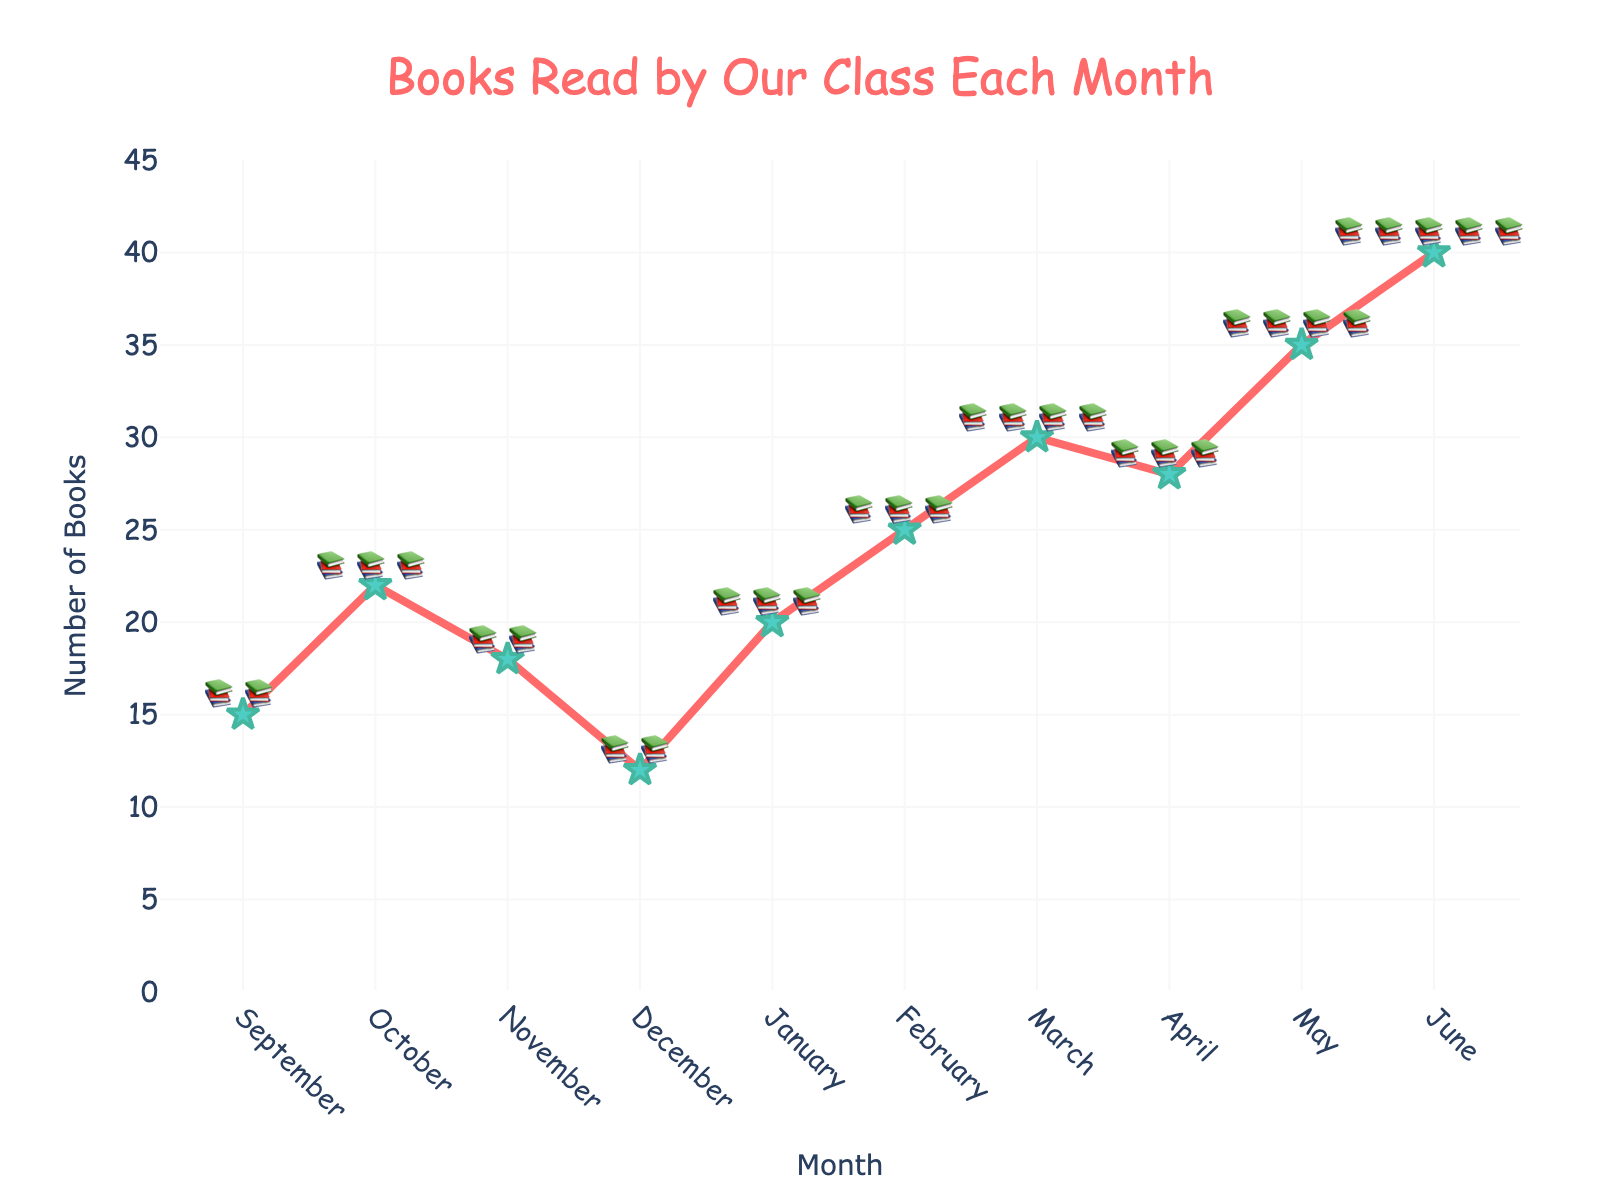Which month did the class read the most books? To figure out which month had the highest number of books read, look at the month with the highest point on the line chart. The highest point is at June, which reaches 40 books.
Answer: June Which month did the class read the least books? Look for the lowest point on the line chart. The lowest point is in December with 12 books read.
Answer: December What is the difference in the number of books read between February and March? First, find the number of books read in February (25) and March (30). Subtract the number in February from the number in March: 30 - 25 = 5.
Answer: 5 How many total books were read in the first half of the school year (from September to February)? Add up the number of books read each month from September to February: 15 (Sept) + 22 (Oct) + 18 (Nov) + 12 (Dec) + 20 (Jan) + 25 (Feb) = 112.
Answer: 112 What is the average number of books read per month over the entire school year? Sum the total number of books read throughout the year and divide by the number of months: (15 + 22 + 18 + 12 + 20 + 25 + 30 + 28 + 35 + 40) / 10 = 24.5.
Answer: 24.5 Which period shows the largest increase in the number of books read compared to the previous month? Compare the difference in the number of books read between each consecutive month and find the greatest increase: 
- October vs. September: 22 - 15 = 7
- November vs. October: 18 - 22 = -4
- December vs. November: 12 - 18 = -6
- January vs. December: 20 - 12 = 8
- February vs. January: 25 - 20 = 5
- March vs. February: 30 - 25 = 5
- April vs. March: 28 - 30 = -2
- May vs. April: 35 - 28 = 7
- June vs. May: 40 - 35 = 5
The largest increase is from December to January: 20 - 12 = 8.
Answer: December to January What percentage of the total books read in the school year were read in the month of May? First, determine the total number of books read in the year: 15 + 22 + 18 + 12 + 20 + 25 + 30 + 28 + 35 + 40 = 245. Then, calculate the percentage for May: (35 / 245) * 100 ≈ 14.29%.
Answer: 14.29% Between which two months did the number of books read decrease the most? Find the months where the difference between consecutive month's book counts is negative and the largest:
- October vs. September: 22 - 15 = 7
- November vs. October: 18 - 22 = -4
- December vs. November: 12 - 18 = -6
- January vs. December: 20 - 12 = 8
- February vs. January: 25 - 20 = 5
- March vs. February: 30 - 25 = 5
- April vs. March: 28 - 30 = -2
- May vs. April: 35 - 28 = 7
- June vs. May: 40 - 35 = 5
The largest decrease is from November to December: 12 - 18 = -6.
Answer: November to December How many months did the class read more than 20 books? Identify the months where the number of books read is greater than 20: October (22), January (20), February (25), March (30), April (28), May (35), June (40). May had exactly 20, so it doesn’t count. There are 6 months where more than 20 books were read.
Answer: 6 